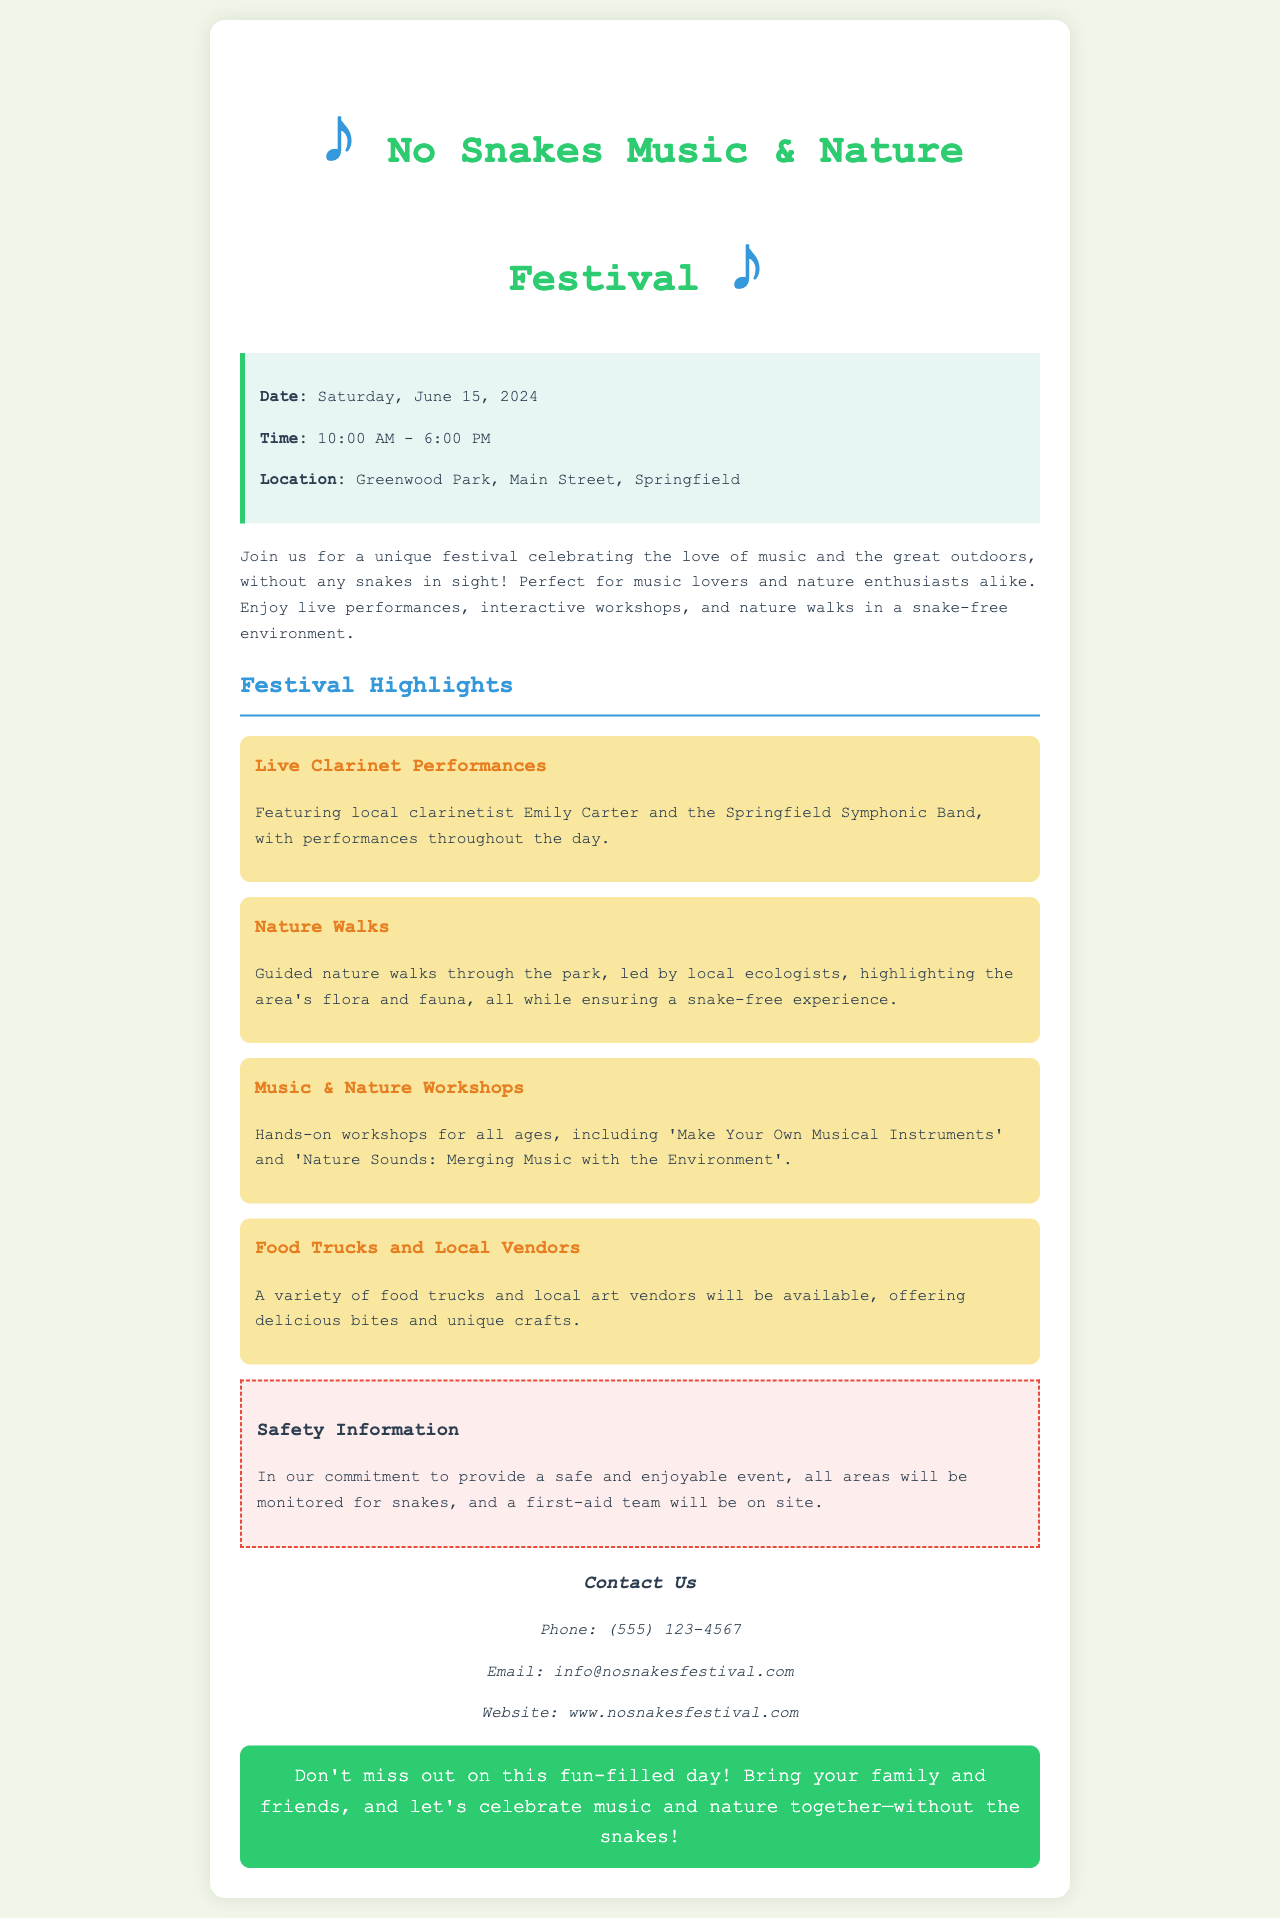What is the date of the festival? The festival is scheduled to take place on Saturday, June 15, 2024.
Answer: June 15, 2024 What time does the festival start? The starting time of the festival is mentioned as 10:00 AM.
Answer: 10:00 AM Where is the festival located? The location of the festival is provided as Greenwood Park, Main Street, Springfield.
Answer: Greenwood Park, Main Street, Springfield Who is a featured performer at the festival? The document highlights local clarinetist Emily Carter as a featured performer.
Answer: Emily Carter What type of workshops are offered? The festival includes workshops such as 'Make Your Own Musical Instruments' and 'Nature Sounds: Merging Music with the Environment'.
Answer: 'Make Your Own Musical Instruments' and 'Nature Sounds: Merging Music with the Environment' What precautions are taken for safety? The festival will monitor all areas for snakes and have a first-aid team on site.
Answer: Monitored for snakes What is the festival's theme? The theme of the festival emphasizes a celebration of music and nature without snakes.
Answer: No Snakes How are local vendors involved in the festival? A variety of food trucks and local art vendors will be present at the festival.
Answer: Food trucks and local vendors What is the contact phone number for the festival? The phone number for contacting the festival is provided as (555) 123-4567.
Answer: (555) 123-4567 